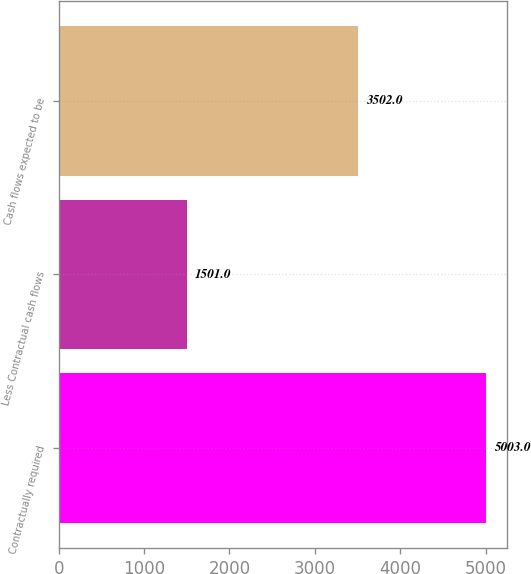<chart> <loc_0><loc_0><loc_500><loc_500><bar_chart><fcel>Contractually required<fcel>Less Contractual cash flows<fcel>Cash flows expected to be<nl><fcel>5003<fcel>1501<fcel>3502<nl></chart> 